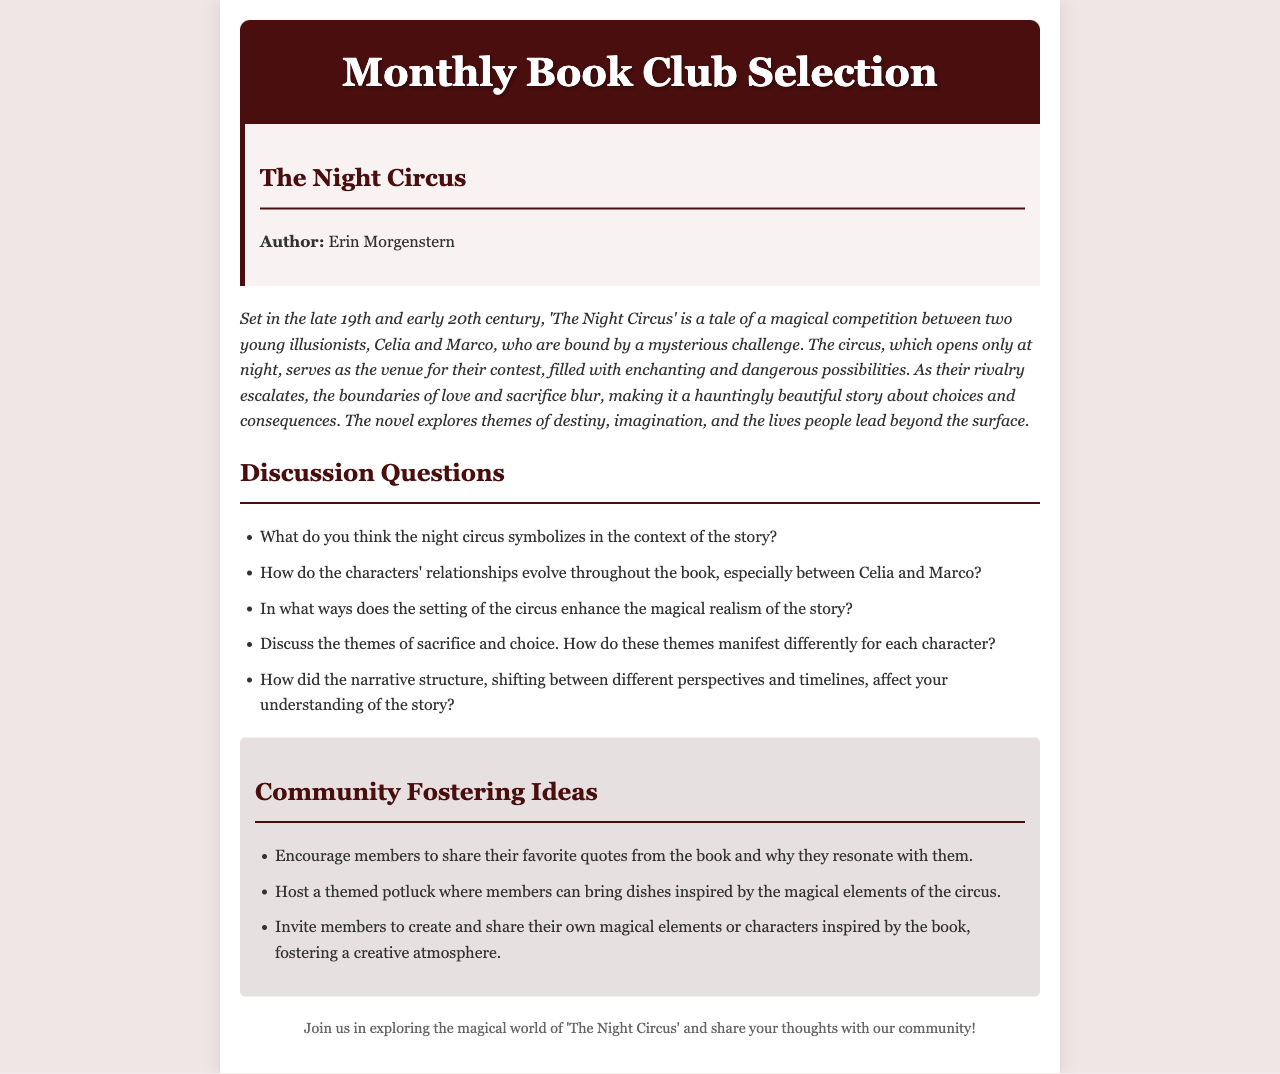What is the title of the book selection? The title of the book selection is explicitly stated in the document's header section at the top, which indicates the current choice for the book club.
Answer: The Night Circus Who is the author of the book? The author's name is mentioned in the book info section, providing clear identification of who wrote the selected book.
Answer: Erin Morgenstern What is the main setting period of 'The Night Circus'? The time frame for the story is included in the summary, giving insight into the historical context in which the narrative takes place.
Answer: Late 19th and early 20th century What do Celia and Marco compete for? The summary explains that Celia and Marco are engaged in a competition, which is crucial to the plot and character development.
Answer: A magical competition How many discussion questions are listed in the document? The number of discussion questions is specified within the list, which directly relates to engagement with the book’s themes and characters.
Answer: Five Which theme is highlighted as a significant element of the story? One of the prominent themes discussed in the summary is included, emphasizing the overarching concepts explored throughout the book.
Answer: Destiny What type of event is suggested for community fostering? The ideas section proposes specific events or activities aimed at enhancing community interaction and connection among members.
Answer: Themed potluck What is the purpose of the email? The main aim of the email is stated in the footer, summarizing the intent behind sharing the book selection and encouraging reader participation.
Answer: Exploring the magical world of 'The Night Circus' 